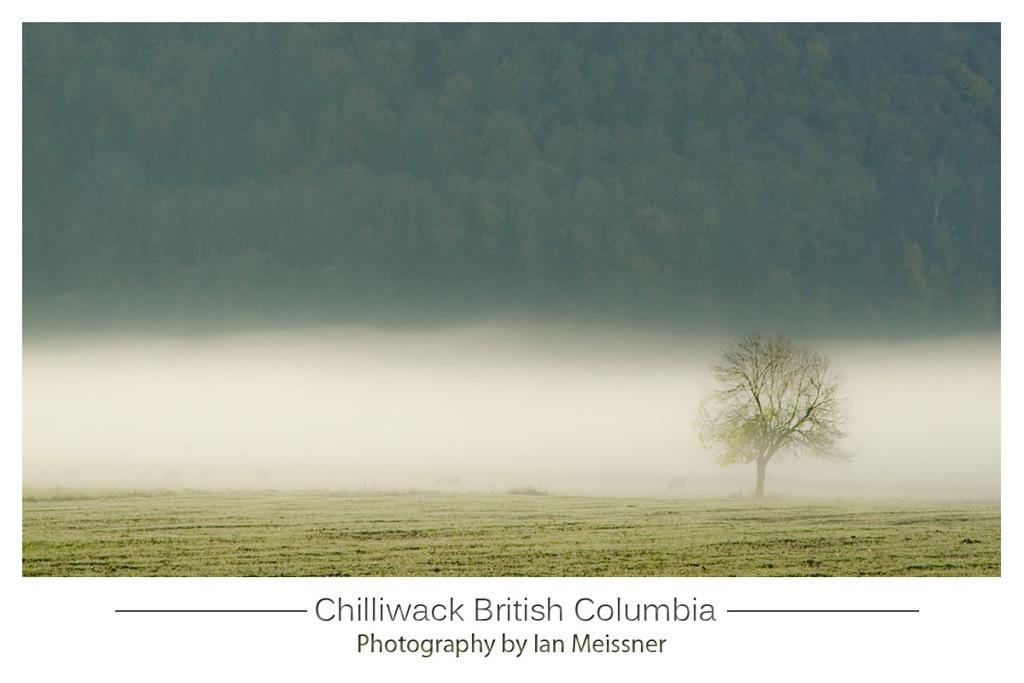What type of vegetation is present on the ground in the image? There is grass on the ground in the image. What can be seen in the distance in the image? There are trees in the background of the image. Is there any text present in the image? Yes, there is text visible at the bottom of the image. Can you tell me how many cords are connected to the trees in the image? There are no cords connected to the trees in the image; only grass, trees, and text are present. What type of pet can be seen playing in the grass in the image? There is no pet present in the image; it only features grass, trees, and text. 